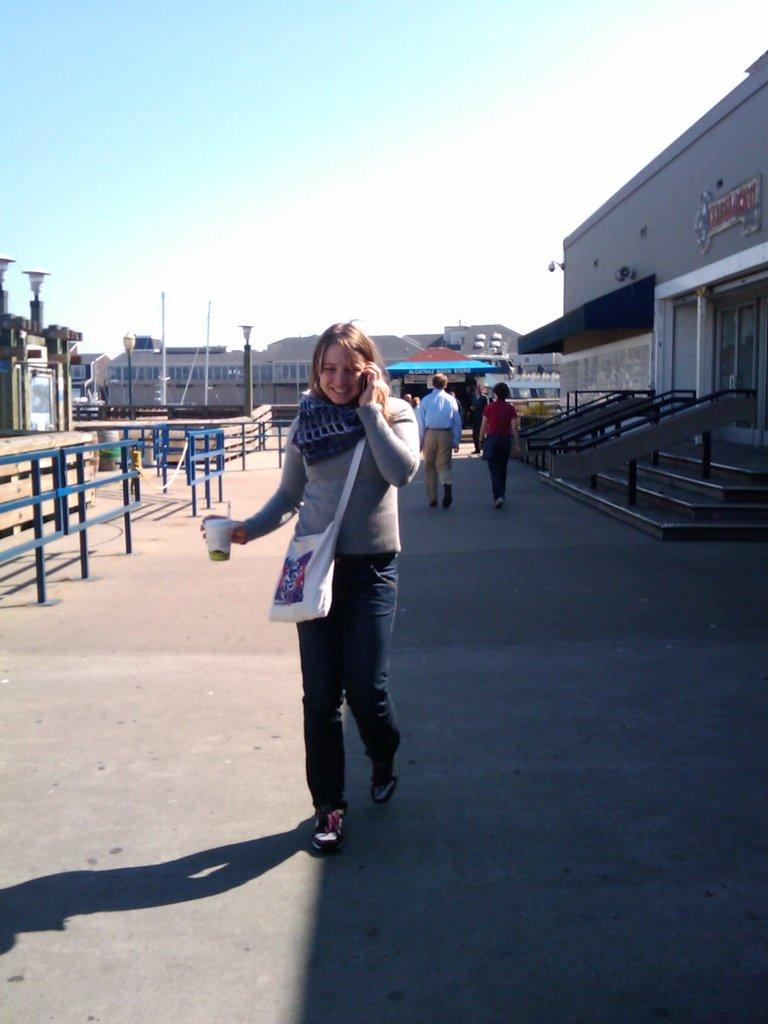What type of structure can be seen in the image? There is railing, a fence, stairs, and buildings visible in the image. Who or what is present in the image? There are people in the image. What architectural features can be seen in the image? There are stairs and light poles visible in the image. What is visible in the background of the image? The sky is visible in the background of the image. What type of cakes are being served at the science conference in the image? There is no reference to a science conference or cakes in the image. 